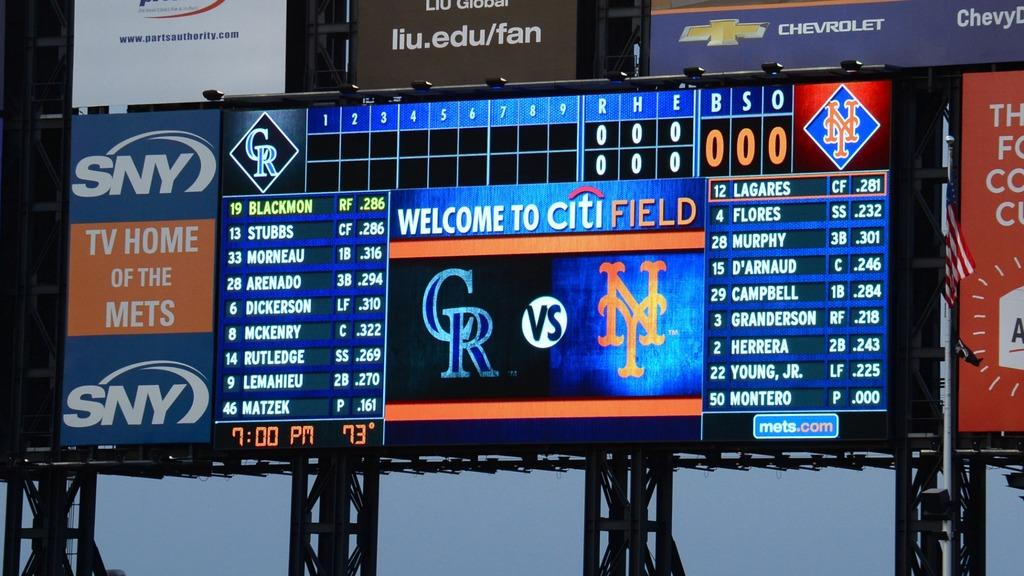<image>
Describe the image concisely. The scoreboard at Citi Field is shows the Colorado Rockies vs the New York Mets. 